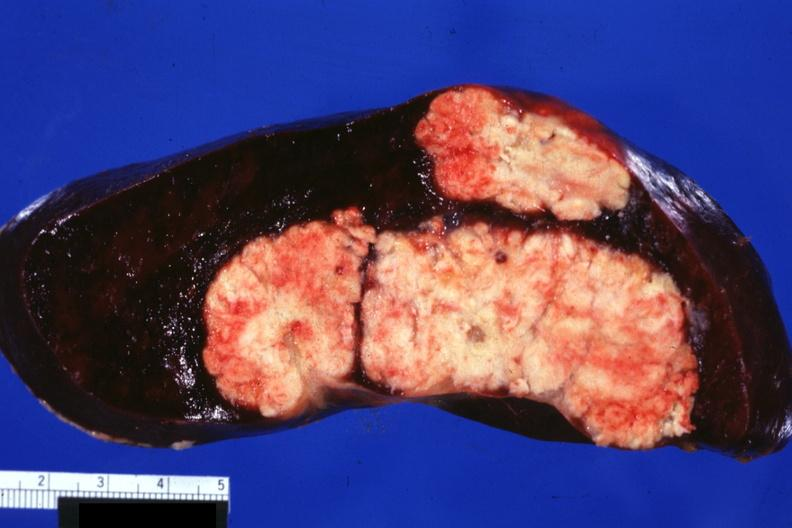s hematologic present?
Answer the question using a single word or phrase. Yes 